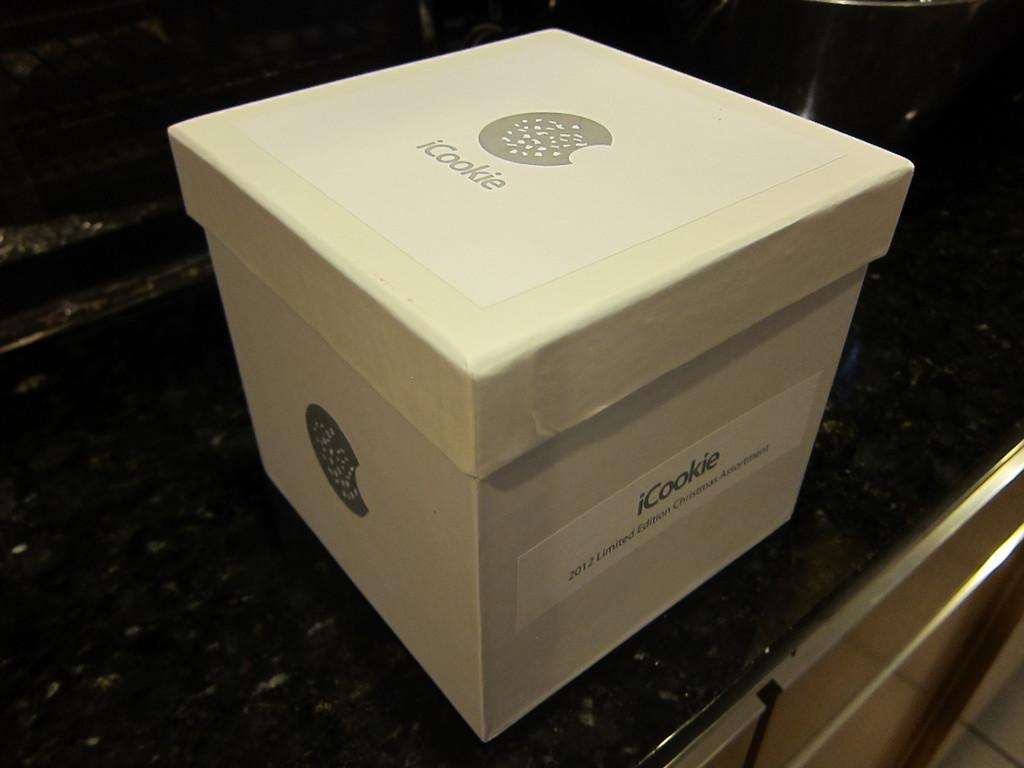<image>
Share a concise interpretation of the image provided. A large, white iCookie box sits on a counter. 